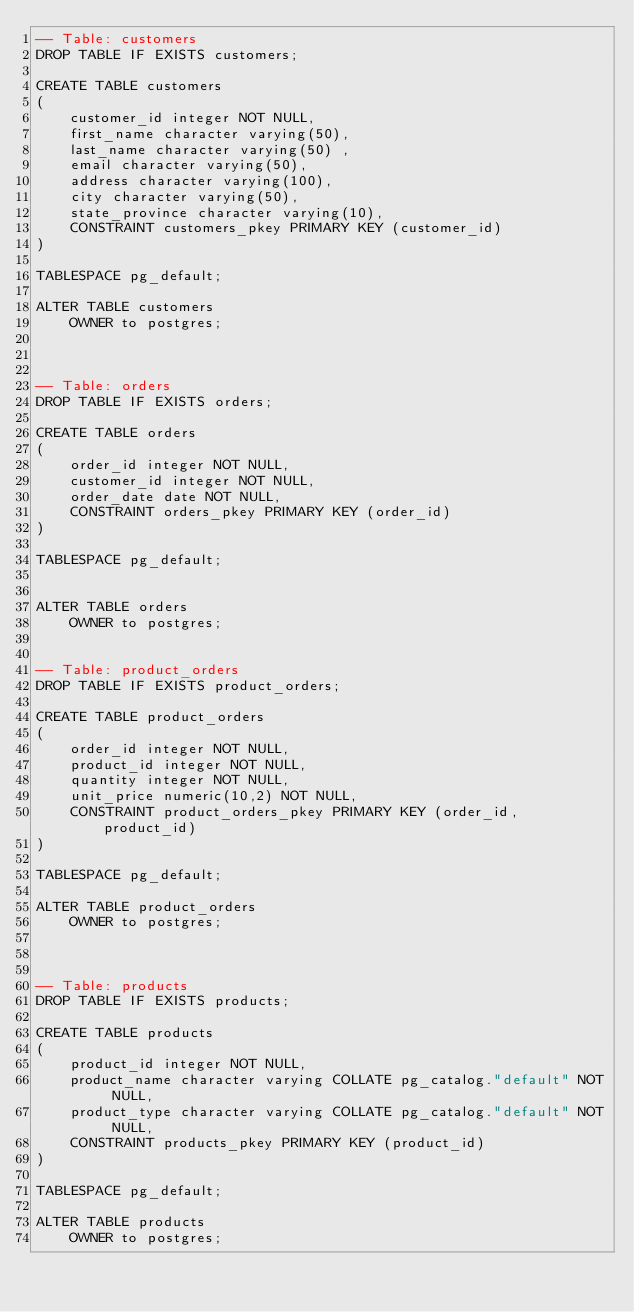Convert code to text. <code><loc_0><loc_0><loc_500><loc_500><_SQL_>-- Table: customers
DROP TABLE IF EXISTS customers;

CREATE TABLE customers
(
    customer_id integer NOT NULL,
    first_name character varying(50),
    last_name character varying(50) ,
    email character varying(50),
    address character varying(100),
    city character varying(50),
    state_province character varying(10),
    CONSTRAINT customers_pkey PRIMARY KEY (customer_id)
)

TABLESPACE pg_default;

ALTER TABLE customers
    OWNER to postgres;



-- Table: orders
DROP TABLE IF EXISTS orders;

CREATE TABLE orders
(
    order_id integer NOT NULL,
    customer_id integer NOT NULL,
    order_date date NOT NULL,
    CONSTRAINT orders_pkey PRIMARY KEY (order_id)
)

TABLESPACE pg_default;


ALTER TABLE orders
    OWNER to postgres;

	
-- Table: product_orders
DROP TABLE IF EXISTS product_orders;

CREATE TABLE product_orders
(
    order_id integer NOT NULL,
    product_id integer NOT NULL,
    quantity integer NOT NULL,
    unit_price numeric(10,2) NOT NULL,
    CONSTRAINT product_orders_pkey PRIMARY KEY (order_id, product_id)
)

TABLESPACE pg_default;

ALTER TABLE product_orders
    OWNER to postgres;



-- Table: products
DROP TABLE IF EXISTS products;

CREATE TABLE products
(
    product_id integer NOT NULL,
    product_name character varying COLLATE pg_catalog."default" NOT NULL,
    product_type character varying COLLATE pg_catalog."default" NOT NULL,
    CONSTRAINT products_pkey PRIMARY KEY (product_id)
)

TABLESPACE pg_default;

ALTER TABLE products
    OWNER to postgres;
</code> 